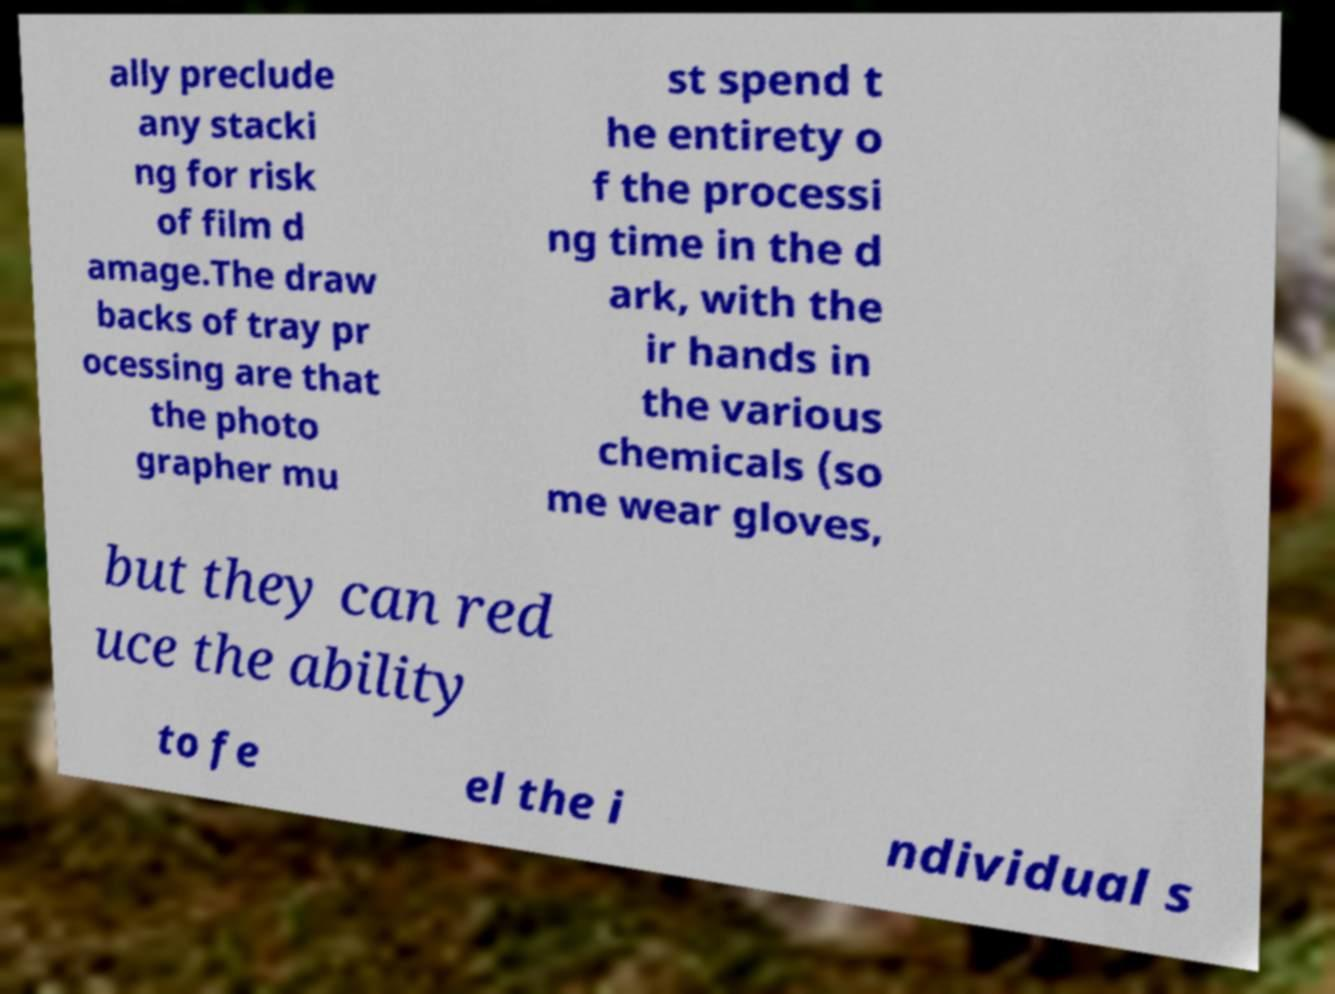Can you read and provide the text displayed in the image?This photo seems to have some interesting text. Can you extract and type it out for me? ally preclude any stacki ng for risk of film d amage.The draw backs of tray pr ocessing are that the photo grapher mu st spend t he entirety o f the processi ng time in the d ark, with the ir hands in the various chemicals (so me wear gloves, but they can red uce the ability to fe el the i ndividual s 